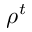Convert formula to latex. <formula><loc_0><loc_0><loc_500><loc_500>\rho ^ { t }</formula> 